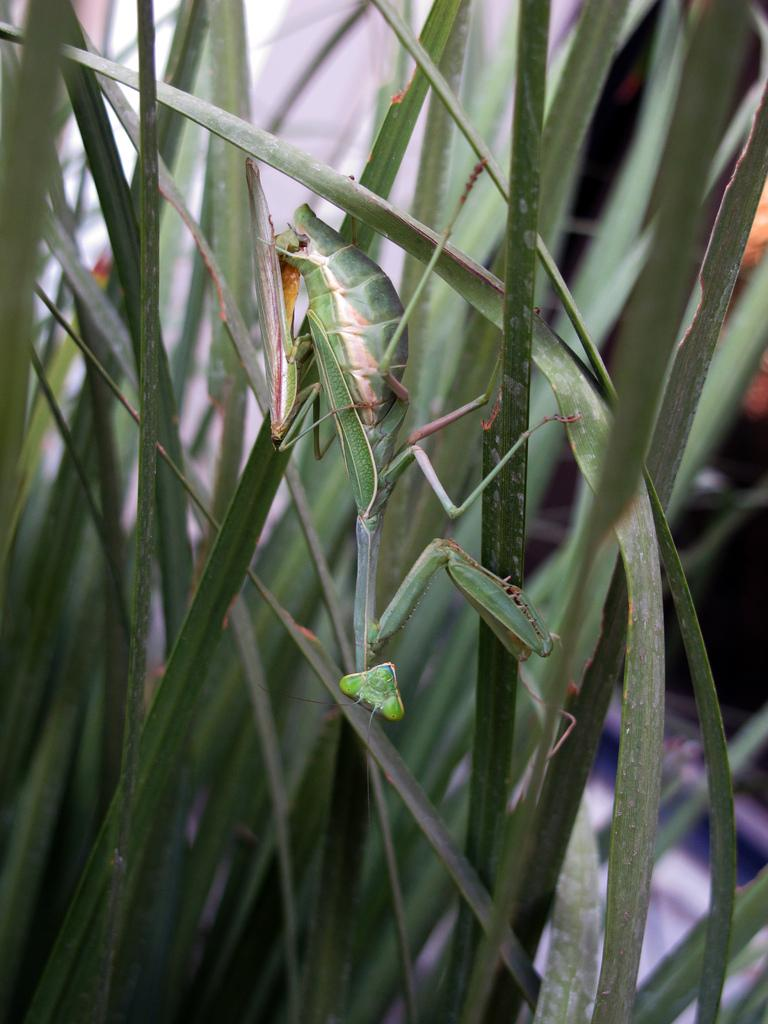What is present in the image? There is an insect in the image. Where is the insect located? The insect is on a plant. What type of fear does the insect exhibit in the image? There is no indication of fear in the image, as insects do not have emotions like humans. 